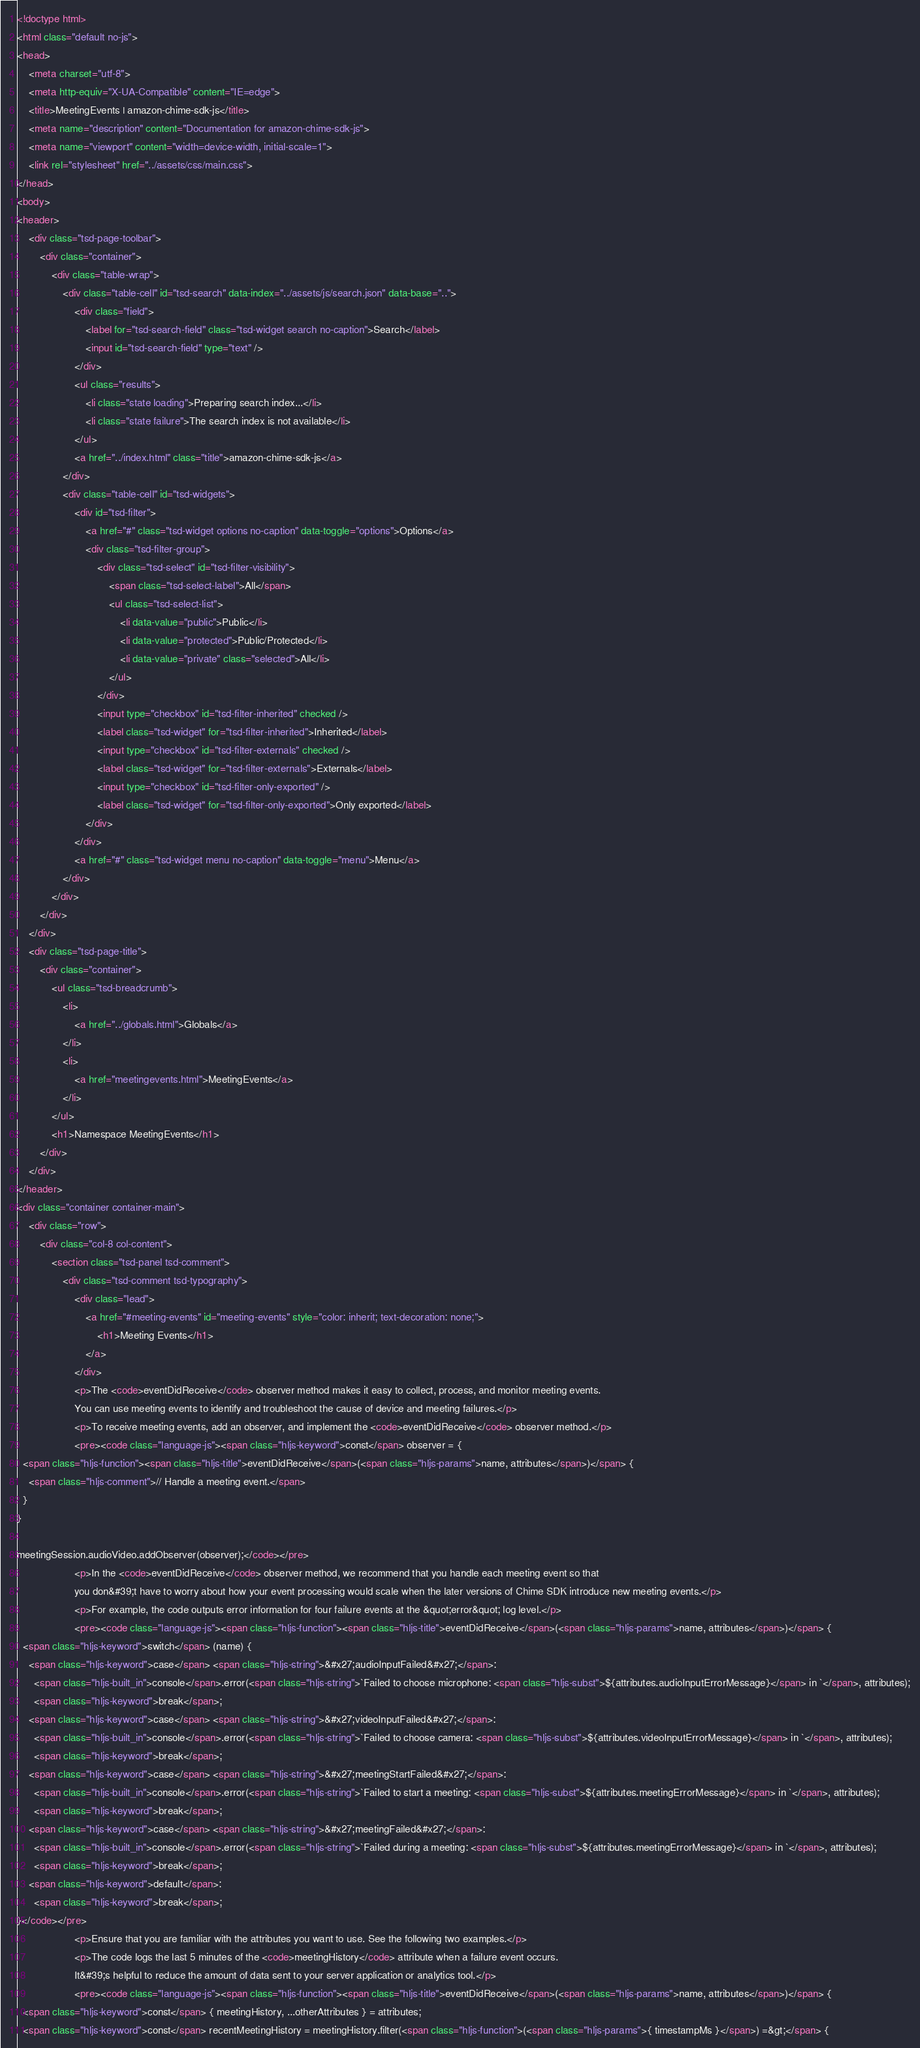<code> <loc_0><loc_0><loc_500><loc_500><_HTML_><!doctype html>
<html class="default no-js">
<head>
	<meta charset="utf-8">
	<meta http-equiv="X-UA-Compatible" content="IE=edge">
	<title>MeetingEvents | amazon-chime-sdk-js</title>
	<meta name="description" content="Documentation for amazon-chime-sdk-js">
	<meta name="viewport" content="width=device-width, initial-scale=1">
	<link rel="stylesheet" href="../assets/css/main.css">
</head>
<body>
<header>
	<div class="tsd-page-toolbar">
		<div class="container">
			<div class="table-wrap">
				<div class="table-cell" id="tsd-search" data-index="../assets/js/search.json" data-base="..">
					<div class="field">
						<label for="tsd-search-field" class="tsd-widget search no-caption">Search</label>
						<input id="tsd-search-field" type="text" />
					</div>
					<ul class="results">
						<li class="state loading">Preparing search index...</li>
						<li class="state failure">The search index is not available</li>
					</ul>
					<a href="../index.html" class="title">amazon-chime-sdk-js</a>
				</div>
				<div class="table-cell" id="tsd-widgets">
					<div id="tsd-filter">
						<a href="#" class="tsd-widget options no-caption" data-toggle="options">Options</a>
						<div class="tsd-filter-group">
							<div class="tsd-select" id="tsd-filter-visibility">
								<span class="tsd-select-label">All</span>
								<ul class="tsd-select-list">
									<li data-value="public">Public</li>
									<li data-value="protected">Public/Protected</li>
									<li data-value="private" class="selected">All</li>
								</ul>
							</div>
							<input type="checkbox" id="tsd-filter-inherited" checked />
							<label class="tsd-widget" for="tsd-filter-inherited">Inherited</label>
							<input type="checkbox" id="tsd-filter-externals" checked />
							<label class="tsd-widget" for="tsd-filter-externals">Externals</label>
							<input type="checkbox" id="tsd-filter-only-exported" />
							<label class="tsd-widget" for="tsd-filter-only-exported">Only exported</label>
						</div>
					</div>
					<a href="#" class="tsd-widget menu no-caption" data-toggle="menu">Menu</a>
				</div>
			</div>
		</div>
	</div>
	<div class="tsd-page-title">
		<div class="container">
			<ul class="tsd-breadcrumb">
				<li>
					<a href="../globals.html">Globals</a>
				</li>
				<li>
					<a href="meetingevents.html">MeetingEvents</a>
				</li>
			</ul>
			<h1>Namespace MeetingEvents</h1>
		</div>
	</div>
</header>
<div class="container container-main">
	<div class="row">
		<div class="col-8 col-content">
			<section class="tsd-panel tsd-comment">
				<div class="tsd-comment tsd-typography">
					<div class="lead">
						<a href="#meeting-events" id="meeting-events" style="color: inherit; text-decoration: none;">
							<h1>Meeting Events</h1>
						</a>
					</div>
					<p>The <code>eventDidReceive</code> observer method makes it easy to collect, process, and monitor meeting events.
					You can use meeting events to identify and troubleshoot the cause of device and meeting failures.</p>
					<p>To receive meeting events, add an observer, and implement the <code>eventDidReceive</code> observer method.</p>
					<pre><code class="language-js"><span class="hljs-keyword">const</span> observer = {
  <span class="hljs-function"><span class="hljs-title">eventDidReceive</span>(<span class="hljs-params">name, attributes</span>)</span> {
    <span class="hljs-comment">// Handle a meeting event.</span>
  }
}

meetingSession.audioVideo.addObserver(observer);</code></pre>
					<p>In the <code>eventDidReceive</code> observer method, we recommend that you handle each meeting event so that
					you don&#39;t have to worry about how your event processing would scale when the later versions of Chime SDK introduce new meeting events.</p>
					<p>For example, the code outputs error information for four failure events at the &quot;error&quot; log level.</p>
					<pre><code class="language-js"><span class="hljs-function"><span class="hljs-title">eventDidReceive</span>(<span class="hljs-params">name, attributes</span>)</span> {
  <span class="hljs-keyword">switch</span> (name) {
    <span class="hljs-keyword">case</span> <span class="hljs-string">&#x27;audioInputFailed&#x27;</span>:
      <span class="hljs-built_in">console</span>.error(<span class="hljs-string">`Failed to choose microphone: <span class="hljs-subst">${attributes.audioInputErrorMessage}</span> in `</span>, attributes);
      <span class="hljs-keyword">break</span>;
    <span class="hljs-keyword">case</span> <span class="hljs-string">&#x27;videoInputFailed&#x27;</span>:
      <span class="hljs-built_in">console</span>.error(<span class="hljs-string">`Failed to choose camera: <span class="hljs-subst">${attributes.videoInputErrorMessage}</span> in `</span>, attributes);
      <span class="hljs-keyword">break</span>;
    <span class="hljs-keyword">case</span> <span class="hljs-string">&#x27;meetingStartFailed&#x27;</span>:
      <span class="hljs-built_in">console</span>.error(<span class="hljs-string">`Failed to start a meeting: <span class="hljs-subst">${attributes.meetingErrorMessage}</span> in `</span>, attributes);
      <span class="hljs-keyword">break</span>;
    <span class="hljs-keyword">case</span> <span class="hljs-string">&#x27;meetingFailed&#x27;</span>:
      <span class="hljs-built_in">console</span>.error(<span class="hljs-string">`Failed during a meeting: <span class="hljs-subst">${attributes.meetingErrorMessage}</span> in `</span>, attributes);
      <span class="hljs-keyword">break</span>;
    <span class="hljs-keyword">default</span>:
      <span class="hljs-keyword">break</span>;
}</code></pre>
					<p>Ensure that you are familiar with the attributes you want to use. See the following two examples.</p>
					<p>The code logs the last 5 minutes of the <code>meetingHistory</code> attribute when a failure event occurs.
					It&#39;s helpful to reduce the amount of data sent to your server application or analytics tool.</p>
					<pre><code class="language-js"><span class="hljs-function"><span class="hljs-title">eventDidReceive</span>(<span class="hljs-params">name, attributes</span>)</span> {
  <span class="hljs-keyword">const</span> { meetingHistory, ...otherAttributes } = attributes;
  <span class="hljs-keyword">const</span> recentMeetingHistory = meetingHistory.filter(<span class="hljs-function">(<span class="hljs-params">{ timestampMs }</span>) =&gt;</span> {</code> 